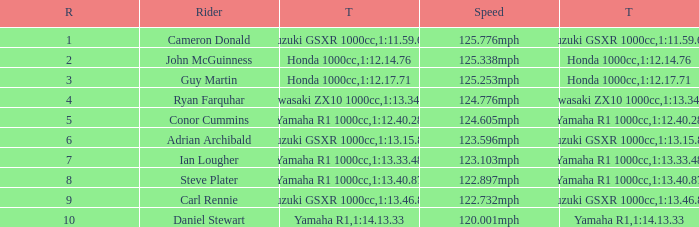What time did team kawasaki zx10 1000cc have? 1:13.34.98. 